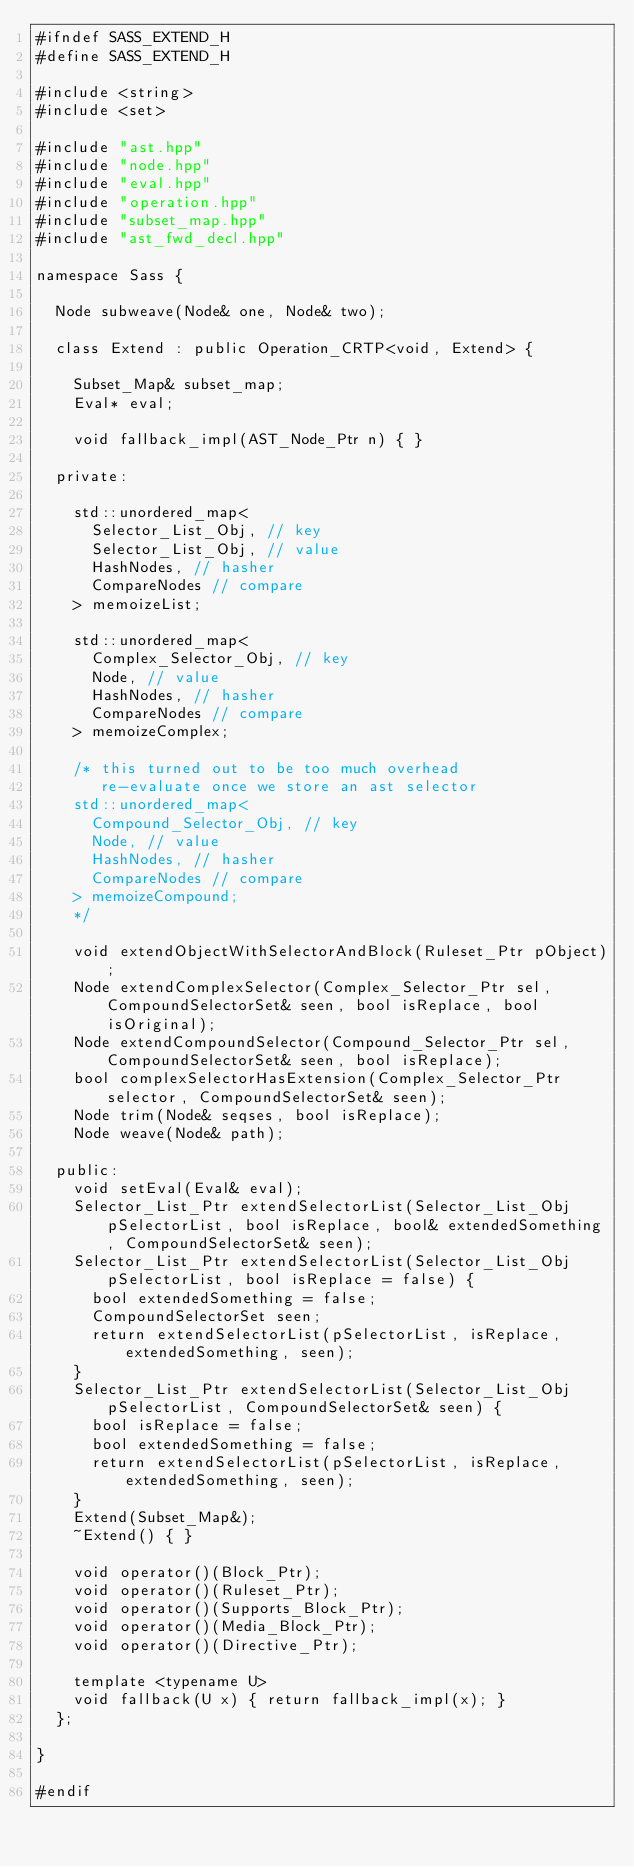<code> <loc_0><loc_0><loc_500><loc_500><_C++_>#ifndef SASS_EXTEND_H
#define SASS_EXTEND_H

#include <string>
#include <set>

#include "ast.hpp"
#include "node.hpp"
#include "eval.hpp"
#include "operation.hpp"
#include "subset_map.hpp"
#include "ast_fwd_decl.hpp"

namespace Sass {

  Node subweave(Node& one, Node& two);

  class Extend : public Operation_CRTP<void, Extend> {

    Subset_Map& subset_map;
    Eval* eval;

    void fallback_impl(AST_Node_Ptr n) { }

  private:

    std::unordered_map<
      Selector_List_Obj, // key
      Selector_List_Obj, // value
      HashNodes, // hasher
      CompareNodes // compare
    > memoizeList;

    std::unordered_map<
      Complex_Selector_Obj, // key
      Node, // value
      HashNodes, // hasher
      CompareNodes // compare
    > memoizeComplex;

    /* this turned out to be too much overhead
       re-evaluate once we store an ast selector
    std::unordered_map<
      Compound_Selector_Obj, // key
      Node, // value
      HashNodes, // hasher
      CompareNodes // compare
    > memoizeCompound;
    */

    void extendObjectWithSelectorAndBlock(Ruleset_Ptr pObject);
    Node extendComplexSelector(Complex_Selector_Ptr sel, CompoundSelectorSet& seen, bool isReplace, bool isOriginal);
    Node extendCompoundSelector(Compound_Selector_Ptr sel, CompoundSelectorSet& seen, bool isReplace);
    bool complexSelectorHasExtension(Complex_Selector_Ptr selector, CompoundSelectorSet& seen);
    Node trim(Node& seqses, bool isReplace);
    Node weave(Node& path);

  public:
    void setEval(Eval& eval);
    Selector_List_Ptr extendSelectorList(Selector_List_Obj pSelectorList, bool isReplace, bool& extendedSomething, CompoundSelectorSet& seen);
    Selector_List_Ptr extendSelectorList(Selector_List_Obj pSelectorList, bool isReplace = false) {
      bool extendedSomething = false;
      CompoundSelectorSet seen;
      return extendSelectorList(pSelectorList, isReplace, extendedSomething, seen);
    }
    Selector_List_Ptr extendSelectorList(Selector_List_Obj pSelectorList, CompoundSelectorSet& seen) {
      bool isReplace = false;
      bool extendedSomething = false;
      return extendSelectorList(pSelectorList, isReplace, extendedSomething, seen);
    }
    Extend(Subset_Map&);
    ~Extend() { }

    void operator()(Block_Ptr);
    void operator()(Ruleset_Ptr);
    void operator()(Supports_Block_Ptr);
    void operator()(Media_Block_Ptr);
    void operator()(Directive_Ptr);

    template <typename U>
    void fallback(U x) { return fallback_impl(x); }
  };

}

#endif
</code> 